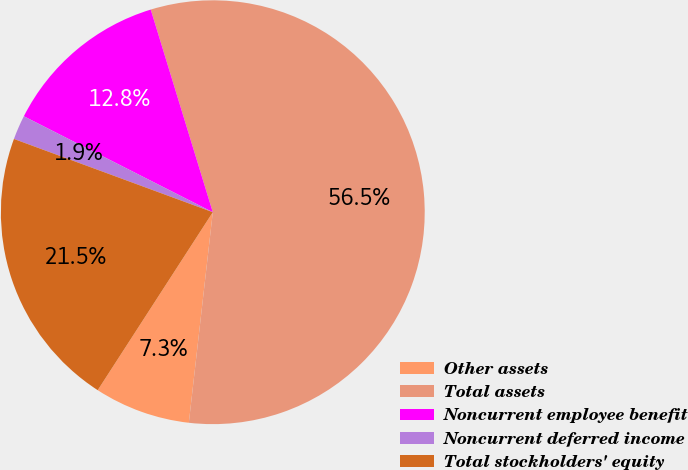<chart> <loc_0><loc_0><loc_500><loc_500><pie_chart><fcel>Other assets<fcel>Total assets<fcel>Noncurrent employee benefit<fcel>Noncurrent deferred income<fcel>Total stockholders' equity<nl><fcel>7.33%<fcel>56.53%<fcel>12.79%<fcel>1.86%<fcel>21.48%<nl></chart> 